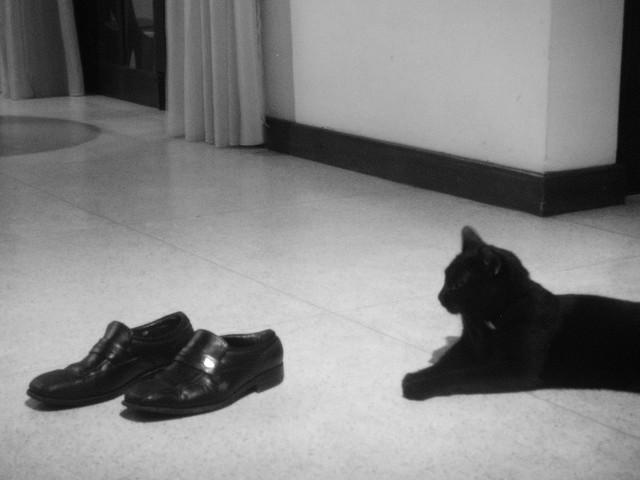Is this a black and white image?
Keep it brief. Yes. What brand of sneaker is the cat's foot on in the bottom picture?
Short answer required. None. Where are the shoes?
Keep it brief. Floor. Whose shoes are these?
Answer briefly. Man's. Where are the curtains?
Be succinct. Left corner. 